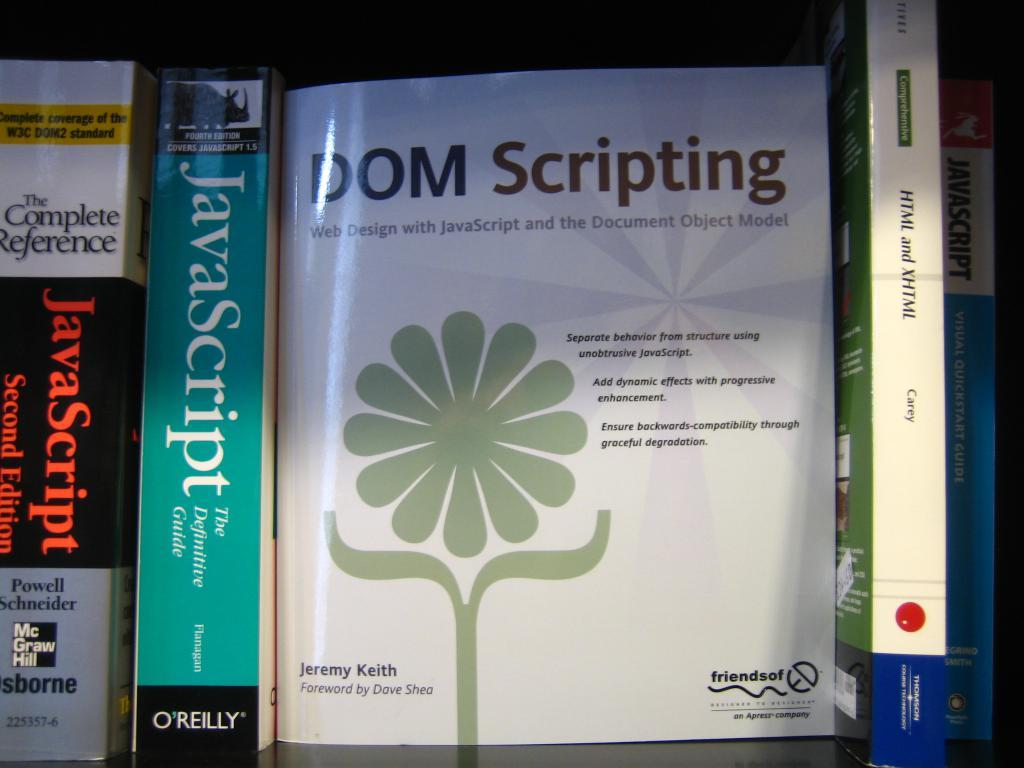<image>
Provide a brief description of the given image. The white book in the middle is called DOM Scripting 